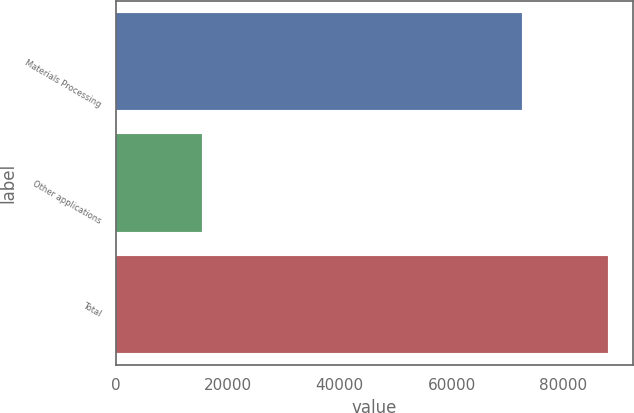Convert chart to OTSL. <chart><loc_0><loc_0><loc_500><loc_500><bar_chart><fcel>Materials Processing<fcel>Other applications<fcel>Total<nl><fcel>72570<fcel>15476<fcel>88046<nl></chart> 